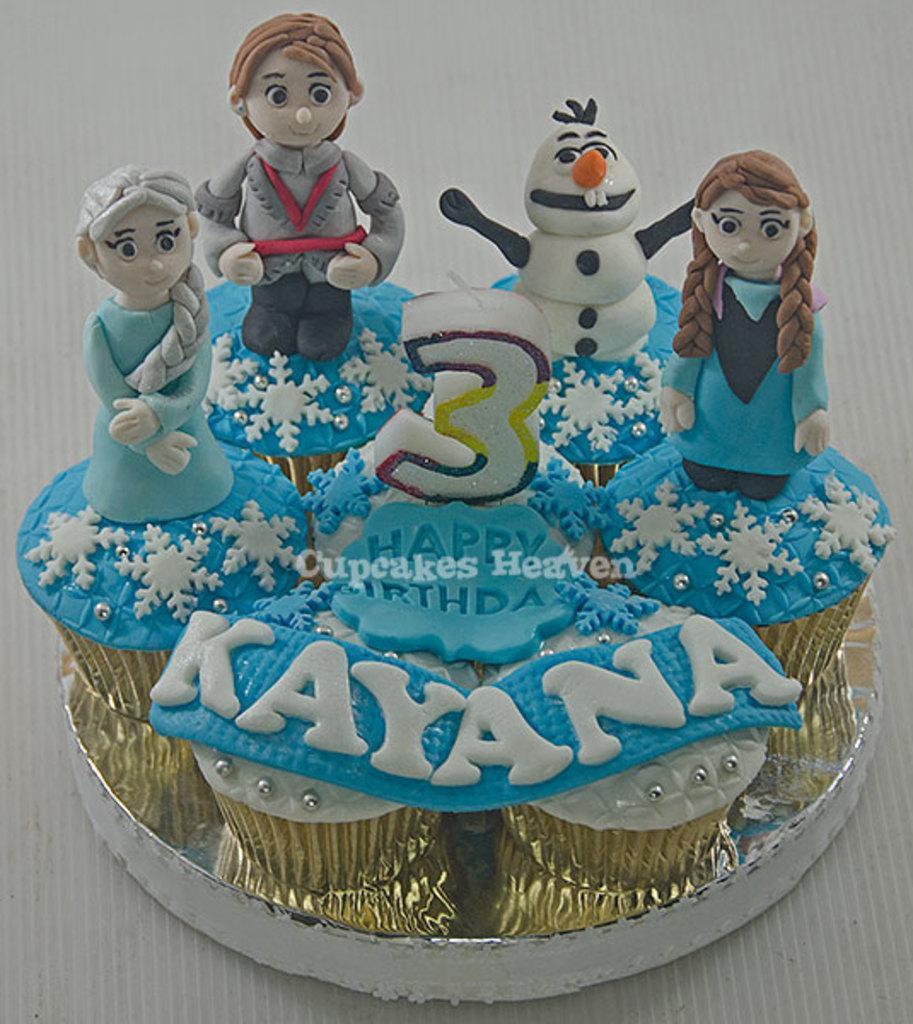In one or two sentences, can you explain what this image depicts? In the center of the image we can see cake placed on the table. 